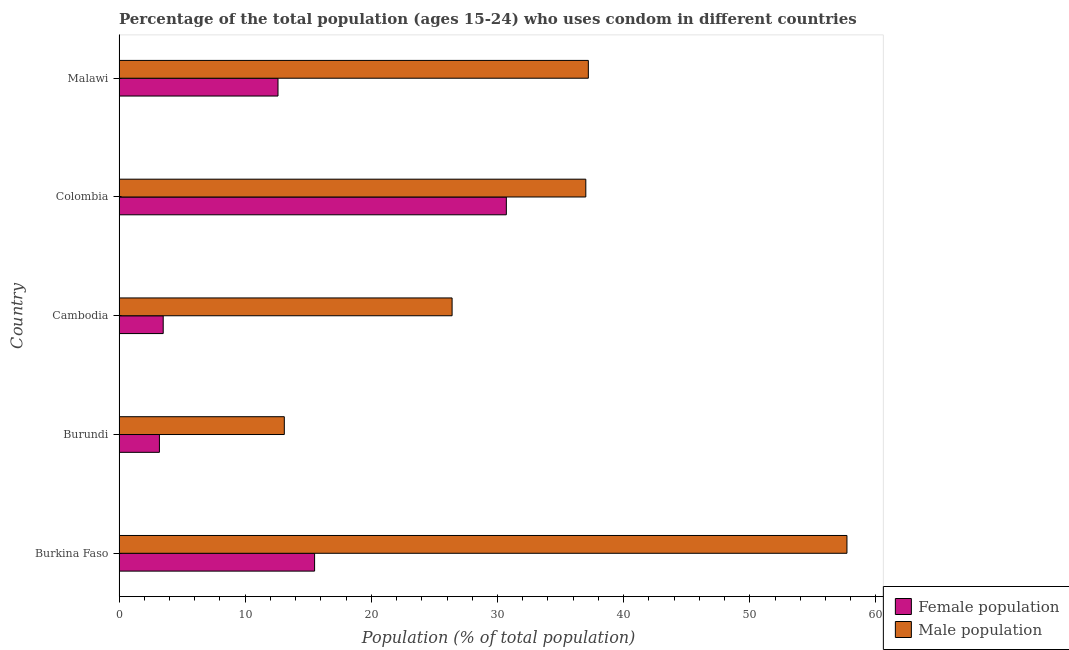How many different coloured bars are there?
Offer a terse response. 2. Are the number of bars per tick equal to the number of legend labels?
Offer a very short reply. Yes. How many bars are there on the 1st tick from the bottom?
Provide a short and direct response. 2. What is the label of the 4th group of bars from the top?
Keep it short and to the point. Burundi. In how many cases, is the number of bars for a given country not equal to the number of legend labels?
Keep it short and to the point. 0. Across all countries, what is the maximum female population?
Provide a succinct answer. 30.7. In which country was the female population minimum?
Provide a short and direct response. Burundi. What is the total female population in the graph?
Make the answer very short. 65.5. What is the difference between the female population in Colombia and that in Malawi?
Your response must be concise. 18.1. What is the difference between the male population in Burkina Faso and the female population in Malawi?
Give a very brief answer. 45.1. What is the difference between the female population and male population in Malawi?
Give a very brief answer. -24.6. What is the ratio of the male population in Burundi to that in Colombia?
Offer a very short reply. 0.35. Is the female population in Burkina Faso less than that in Cambodia?
Provide a succinct answer. No. What is the difference between the highest and the lowest male population?
Your answer should be compact. 44.6. Is the sum of the female population in Cambodia and Malawi greater than the maximum male population across all countries?
Offer a very short reply. No. What does the 2nd bar from the top in Colombia represents?
Give a very brief answer. Female population. What does the 1st bar from the bottom in Malawi represents?
Make the answer very short. Female population. How many bars are there?
Provide a short and direct response. 10. Are the values on the major ticks of X-axis written in scientific E-notation?
Provide a short and direct response. No. Does the graph contain grids?
Offer a very short reply. No. How many legend labels are there?
Offer a terse response. 2. How are the legend labels stacked?
Provide a short and direct response. Vertical. What is the title of the graph?
Ensure brevity in your answer.  Percentage of the total population (ages 15-24) who uses condom in different countries. What is the label or title of the X-axis?
Offer a terse response. Population (% of total population) . What is the label or title of the Y-axis?
Make the answer very short. Country. What is the Population (% of total population)  of Female population in Burkina Faso?
Make the answer very short. 15.5. What is the Population (% of total population)  in Male population in Burkina Faso?
Ensure brevity in your answer.  57.7. What is the Population (% of total population)  in Female population in Burundi?
Give a very brief answer. 3.2. What is the Population (% of total population)  of Male population in Burundi?
Keep it short and to the point. 13.1. What is the Population (% of total population)  in Male population in Cambodia?
Give a very brief answer. 26.4. What is the Population (% of total population)  of Female population in Colombia?
Offer a very short reply. 30.7. What is the Population (% of total population)  of Male population in Colombia?
Offer a terse response. 37. What is the Population (% of total population)  in Male population in Malawi?
Provide a short and direct response. 37.2. Across all countries, what is the maximum Population (% of total population)  in Female population?
Your answer should be very brief. 30.7. Across all countries, what is the maximum Population (% of total population)  in Male population?
Your answer should be very brief. 57.7. Across all countries, what is the minimum Population (% of total population)  of Male population?
Make the answer very short. 13.1. What is the total Population (% of total population)  of Female population in the graph?
Your response must be concise. 65.5. What is the total Population (% of total population)  in Male population in the graph?
Your answer should be compact. 171.4. What is the difference between the Population (% of total population)  of Female population in Burkina Faso and that in Burundi?
Your response must be concise. 12.3. What is the difference between the Population (% of total population)  in Male population in Burkina Faso and that in Burundi?
Offer a very short reply. 44.6. What is the difference between the Population (% of total population)  of Male population in Burkina Faso and that in Cambodia?
Provide a succinct answer. 31.3. What is the difference between the Population (% of total population)  of Female population in Burkina Faso and that in Colombia?
Give a very brief answer. -15.2. What is the difference between the Population (% of total population)  of Male population in Burkina Faso and that in Colombia?
Your response must be concise. 20.7. What is the difference between the Population (% of total population)  in Female population in Burkina Faso and that in Malawi?
Offer a very short reply. 2.9. What is the difference between the Population (% of total population)  of Male population in Burkina Faso and that in Malawi?
Keep it short and to the point. 20.5. What is the difference between the Population (% of total population)  in Female population in Burundi and that in Cambodia?
Your answer should be compact. -0.3. What is the difference between the Population (% of total population)  in Female population in Burundi and that in Colombia?
Provide a short and direct response. -27.5. What is the difference between the Population (% of total population)  in Male population in Burundi and that in Colombia?
Your answer should be very brief. -23.9. What is the difference between the Population (% of total population)  in Male population in Burundi and that in Malawi?
Offer a terse response. -24.1. What is the difference between the Population (% of total population)  of Female population in Cambodia and that in Colombia?
Provide a short and direct response. -27.2. What is the difference between the Population (% of total population)  in Female population in Colombia and that in Malawi?
Ensure brevity in your answer.  18.1. What is the difference between the Population (% of total population)  in Female population in Burkina Faso and the Population (% of total population)  in Male population in Burundi?
Give a very brief answer. 2.4. What is the difference between the Population (% of total population)  in Female population in Burkina Faso and the Population (% of total population)  in Male population in Cambodia?
Provide a succinct answer. -10.9. What is the difference between the Population (% of total population)  in Female population in Burkina Faso and the Population (% of total population)  in Male population in Colombia?
Make the answer very short. -21.5. What is the difference between the Population (% of total population)  in Female population in Burkina Faso and the Population (% of total population)  in Male population in Malawi?
Ensure brevity in your answer.  -21.7. What is the difference between the Population (% of total population)  in Female population in Burundi and the Population (% of total population)  in Male population in Cambodia?
Your answer should be compact. -23.2. What is the difference between the Population (% of total population)  in Female population in Burundi and the Population (% of total population)  in Male population in Colombia?
Give a very brief answer. -33.8. What is the difference between the Population (% of total population)  in Female population in Burundi and the Population (% of total population)  in Male population in Malawi?
Offer a very short reply. -34. What is the difference between the Population (% of total population)  of Female population in Cambodia and the Population (% of total population)  of Male population in Colombia?
Your answer should be very brief. -33.5. What is the difference between the Population (% of total population)  in Female population in Cambodia and the Population (% of total population)  in Male population in Malawi?
Make the answer very short. -33.7. What is the difference between the Population (% of total population)  of Female population in Colombia and the Population (% of total population)  of Male population in Malawi?
Provide a short and direct response. -6.5. What is the average Population (% of total population)  in Female population per country?
Make the answer very short. 13.1. What is the average Population (% of total population)  of Male population per country?
Your response must be concise. 34.28. What is the difference between the Population (% of total population)  in Female population and Population (% of total population)  in Male population in Burkina Faso?
Your answer should be very brief. -42.2. What is the difference between the Population (% of total population)  of Female population and Population (% of total population)  of Male population in Cambodia?
Keep it short and to the point. -22.9. What is the difference between the Population (% of total population)  in Female population and Population (% of total population)  in Male population in Colombia?
Your response must be concise. -6.3. What is the difference between the Population (% of total population)  of Female population and Population (% of total population)  of Male population in Malawi?
Your response must be concise. -24.6. What is the ratio of the Population (% of total population)  in Female population in Burkina Faso to that in Burundi?
Give a very brief answer. 4.84. What is the ratio of the Population (% of total population)  in Male population in Burkina Faso to that in Burundi?
Your answer should be very brief. 4.4. What is the ratio of the Population (% of total population)  of Female population in Burkina Faso to that in Cambodia?
Your answer should be very brief. 4.43. What is the ratio of the Population (% of total population)  in Male population in Burkina Faso to that in Cambodia?
Provide a short and direct response. 2.19. What is the ratio of the Population (% of total population)  in Female population in Burkina Faso to that in Colombia?
Make the answer very short. 0.5. What is the ratio of the Population (% of total population)  of Male population in Burkina Faso to that in Colombia?
Your response must be concise. 1.56. What is the ratio of the Population (% of total population)  of Female population in Burkina Faso to that in Malawi?
Give a very brief answer. 1.23. What is the ratio of the Population (% of total population)  in Male population in Burkina Faso to that in Malawi?
Keep it short and to the point. 1.55. What is the ratio of the Population (% of total population)  in Female population in Burundi to that in Cambodia?
Provide a short and direct response. 0.91. What is the ratio of the Population (% of total population)  in Male population in Burundi to that in Cambodia?
Ensure brevity in your answer.  0.5. What is the ratio of the Population (% of total population)  in Female population in Burundi to that in Colombia?
Make the answer very short. 0.1. What is the ratio of the Population (% of total population)  of Male population in Burundi to that in Colombia?
Ensure brevity in your answer.  0.35. What is the ratio of the Population (% of total population)  in Female population in Burundi to that in Malawi?
Offer a terse response. 0.25. What is the ratio of the Population (% of total population)  of Male population in Burundi to that in Malawi?
Your answer should be very brief. 0.35. What is the ratio of the Population (% of total population)  in Female population in Cambodia to that in Colombia?
Make the answer very short. 0.11. What is the ratio of the Population (% of total population)  in Male population in Cambodia to that in Colombia?
Provide a short and direct response. 0.71. What is the ratio of the Population (% of total population)  of Female population in Cambodia to that in Malawi?
Your answer should be compact. 0.28. What is the ratio of the Population (% of total population)  of Male population in Cambodia to that in Malawi?
Give a very brief answer. 0.71. What is the ratio of the Population (% of total population)  of Female population in Colombia to that in Malawi?
Make the answer very short. 2.44. What is the ratio of the Population (% of total population)  of Male population in Colombia to that in Malawi?
Give a very brief answer. 0.99. What is the difference between the highest and the second highest Population (% of total population)  in Male population?
Make the answer very short. 20.5. What is the difference between the highest and the lowest Population (% of total population)  in Female population?
Give a very brief answer. 27.5. What is the difference between the highest and the lowest Population (% of total population)  in Male population?
Your answer should be compact. 44.6. 